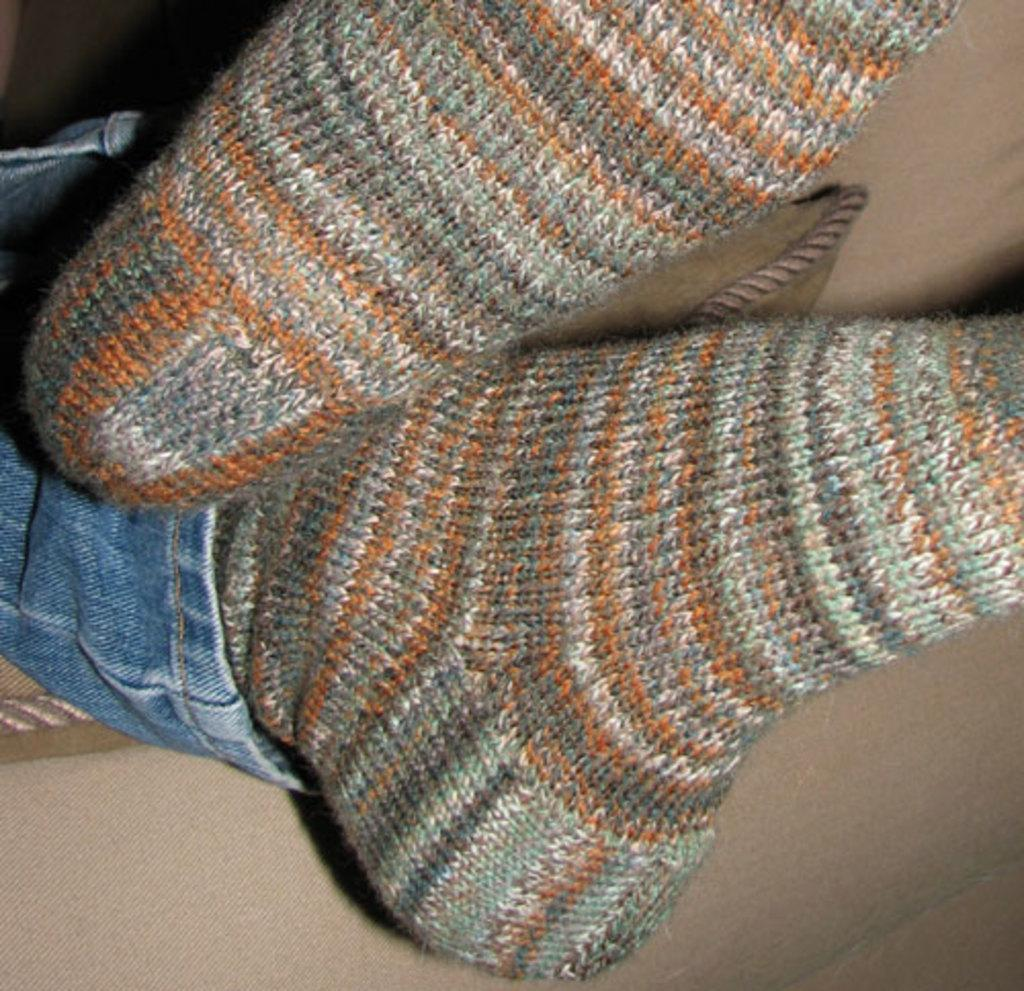What part of a person can be seen in the image? There are legs of a person visible in the image. Can you describe the setting of the image? The image is likely taken in a room. What type of park can be seen in the image? There is no park visible in the image; it is focused on the legs of a person in-frame person in a room. 